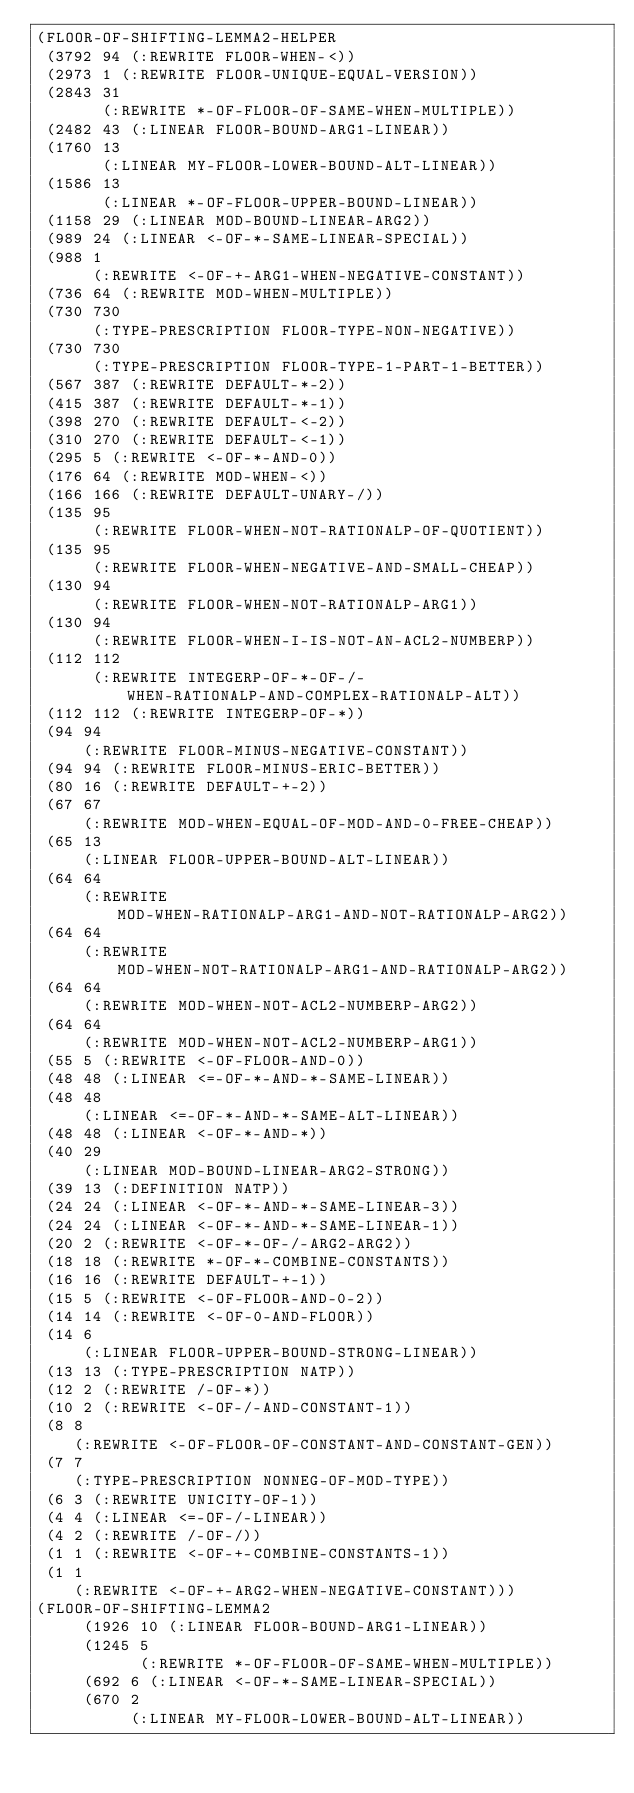Convert code to text. <code><loc_0><loc_0><loc_500><loc_500><_Lisp_>(FLOOR-OF-SHIFTING-LEMMA2-HELPER
 (3792 94 (:REWRITE FLOOR-WHEN-<))
 (2973 1 (:REWRITE FLOOR-UNIQUE-EQUAL-VERSION))
 (2843 31
       (:REWRITE *-OF-FLOOR-OF-SAME-WHEN-MULTIPLE))
 (2482 43 (:LINEAR FLOOR-BOUND-ARG1-LINEAR))
 (1760 13
       (:LINEAR MY-FLOOR-LOWER-BOUND-ALT-LINEAR))
 (1586 13
       (:LINEAR *-OF-FLOOR-UPPER-BOUND-LINEAR))
 (1158 29 (:LINEAR MOD-BOUND-LINEAR-ARG2))
 (989 24 (:LINEAR <-OF-*-SAME-LINEAR-SPECIAL))
 (988 1
      (:REWRITE <-OF-+-ARG1-WHEN-NEGATIVE-CONSTANT))
 (736 64 (:REWRITE MOD-WHEN-MULTIPLE))
 (730 730
      (:TYPE-PRESCRIPTION FLOOR-TYPE-NON-NEGATIVE))
 (730 730
      (:TYPE-PRESCRIPTION FLOOR-TYPE-1-PART-1-BETTER))
 (567 387 (:REWRITE DEFAULT-*-2))
 (415 387 (:REWRITE DEFAULT-*-1))
 (398 270 (:REWRITE DEFAULT-<-2))
 (310 270 (:REWRITE DEFAULT-<-1))
 (295 5 (:REWRITE <-OF-*-AND-0))
 (176 64 (:REWRITE MOD-WHEN-<))
 (166 166 (:REWRITE DEFAULT-UNARY-/))
 (135 95
      (:REWRITE FLOOR-WHEN-NOT-RATIONALP-OF-QUOTIENT))
 (135 95
      (:REWRITE FLOOR-WHEN-NEGATIVE-AND-SMALL-CHEAP))
 (130 94
      (:REWRITE FLOOR-WHEN-NOT-RATIONALP-ARG1))
 (130 94
      (:REWRITE FLOOR-WHEN-I-IS-NOT-AN-ACL2-NUMBERP))
 (112 112
      (:REWRITE INTEGERP-OF-*-OF-/-WHEN-RATIONALP-AND-COMPLEX-RATIONALP-ALT))
 (112 112 (:REWRITE INTEGERP-OF-*))
 (94 94
     (:REWRITE FLOOR-MINUS-NEGATIVE-CONSTANT))
 (94 94 (:REWRITE FLOOR-MINUS-ERIC-BETTER))
 (80 16 (:REWRITE DEFAULT-+-2))
 (67 67
     (:REWRITE MOD-WHEN-EQUAL-OF-MOD-AND-0-FREE-CHEAP))
 (65 13
     (:LINEAR FLOOR-UPPER-BOUND-ALT-LINEAR))
 (64 64
     (:REWRITE MOD-WHEN-RATIONALP-ARG1-AND-NOT-RATIONALP-ARG2))
 (64 64
     (:REWRITE MOD-WHEN-NOT-RATIONALP-ARG1-AND-RATIONALP-ARG2))
 (64 64
     (:REWRITE MOD-WHEN-NOT-ACL2-NUMBERP-ARG2))
 (64 64
     (:REWRITE MOD-WHEN-NOT-ACL2-NUMBERP-ARG1))
 (55 5 (:REWRITE <-OF-FLOOR-AND-0))
 (48 48 (:LINEAR <=-OF-*-AND-*-SAME-LINEAR))
 (48 48
     (:LINEAR <=-OF-*-AND-*-SAME-ALT-LINEAR))
 (48 48 (:LINEAR <-OF-*-AND-*))
 (40 29
     (:LINEAR MOD-BOUND-LINEAR-ARG2-STRONG))
 (39 13 (:DEFINITION NATP))
 (24 24 (:LINEAR <-OF-*-AND-*-SAME-LINEAR-3))
 (24 24 (:LINEAR <-OF-*-AND-*-SAME-LINEAR-1))
 (20 2 (:REWRITE <-OF-*-OF-/-ARG2-ARG2))
 (18 18 (:REWRITE *-OF-*-COMBINE-CONSTANTS))
 (16 16 (:REWRITE DEFAULT-+-1))
 (15 5 (:REWRITE <-OF-FLOOR-AND-0-2))
 (14 14 (:REWRITE <-OF-0-AND-FLOOR))
 (14 6
     (:LINEAR FLOOR-UPPER-BOUND-STRONG-LINEAR))
 (13 13 (:TYPE-PRESCRIPTION NATP))
 (12 2 (:REWRITE /-OF-*))
 (10 2 (:REWRITE <-OF-/-AND-CONSTANT-1))
 (8 8
    (:REWRITE <-OF-FLOOR-OF-CONSTANT-AND-CONSTANT-GEN))
 (7 7
    (:TYPE-PRESCRIPTION NONNEG-OF-MOD-TYPE))
 (6 3 (:REWRITE UNICITY-OF-1))
 (4 4 (:LINEAR <=-OF-/-LINEAR))
 (4 2 (:REWRITE /-OF-/))
 (1 1 (:REWRITE <-OF-+-COMBINE-CONSTANTS-1))
 (1 1
    (:REWRITE <-OF-+-ARG2-WHEN-NEGATIVE-CONSTANT)))
(FLOOR-OF-SHIFTING-LEMMA2
     (1926 10 (:LINEAR FLOOR-BOUND-ARG1-LINEAR))
     (1245 5
           (:REWRITE *-OF-FLOOR-OF-SAME-WHEN-MULTIPLE))
     (692 6 (:LINEAR <-OF-*-SAME-LINEAR-SPECIAL))
     (670 2
          (:LINEAR MY-FLOOR-LOWER-BOUND-ALT-LINEAR))</code> 